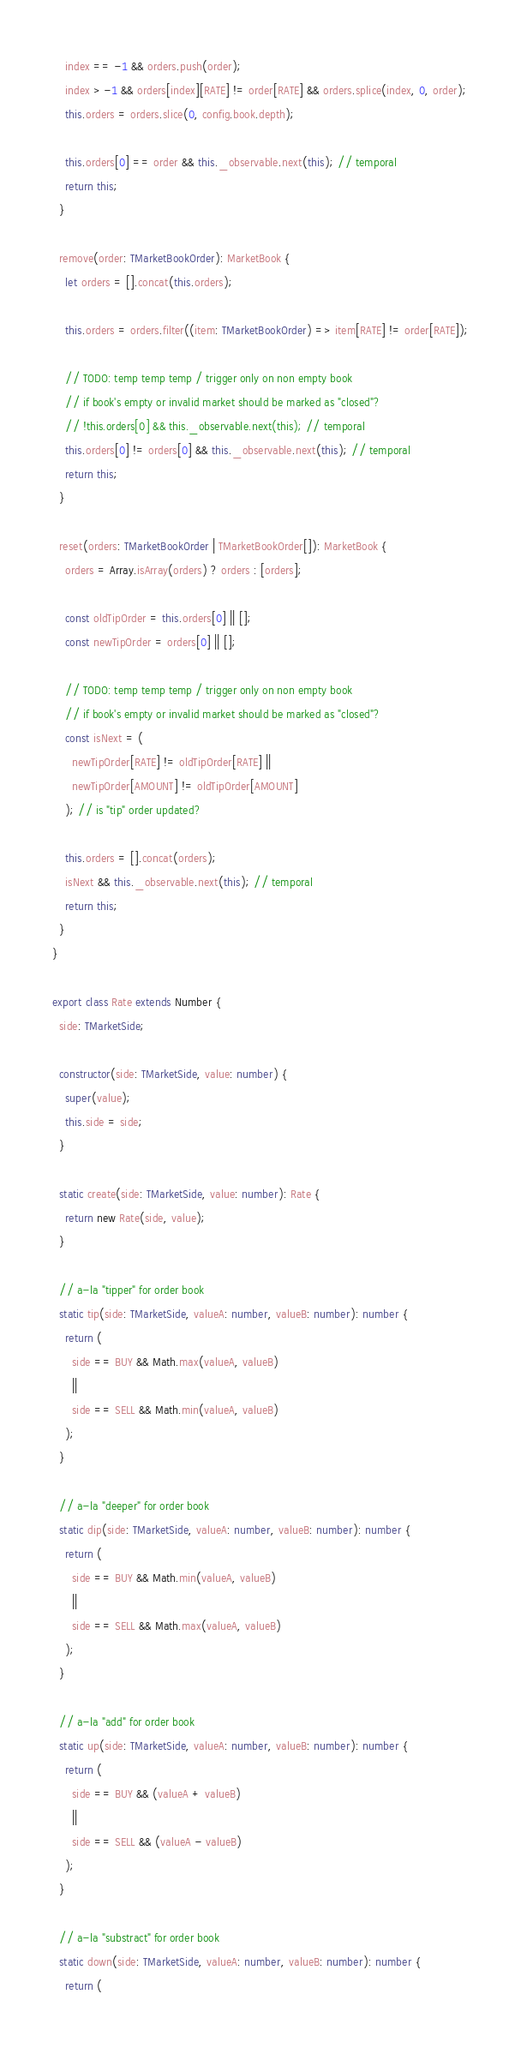<code> <loc_0><loc_0><loc_500><loc_500><_TypeScript_>    index == -1 && orders.push(order);
    index > -1 && orders[index][RATE] != order[RATE] && orders.splice(index, 0, order);
    this.orders = orders.slice(0, config.book.depth);

    this.orders[0] == order && this._observable.next(this); // temporal
    return this;
  }

  remove(order: TMarketBookOrder): MarketBook {
    let orders = [].concat(this.orders);

    this.orders = orders.filter((item: TMarketBookOrder) => item[RATE] != order[RATE]);

    // TODO: temp temp temp / trigger only on non empty book 
    // if book's empty or invalid market should be marked as "closed"?
    // !this.orders[0] && this._observable.next(this); // temporal
    this.orders[0] != orders[0] && this._observable.next(this); // temporal
    return this;
  }

  reset(orders: TMarketBookOrder | TMarketBookOrder[]): MarketBook {
    orders = Array.isArray(orders) ? orders : [orders];

    const oldTipOrder = this.orders[0] || [];
    const newTipOrder = orders[0] || [];

    // TODO: temp temp temp / trigger only on non empty book 
    // if book's empty or invalid market should be marked as "closed"?
    const isNext = (
      newTipOrder[RATE] != oldTipOrder[RATE] ||
      newTipOrder[AMOUNT] != oldTipOrder[AMOUNT]
    ); // is "tip" order updated?

    this.orders = [].concat(orders);
    isNext && this._observable.next(this); // temporal
    return this;
  }
}

export class Rate extends Number {
  side: TMarketSide;

  constructor(side: TMarketSide, value: number) {
    super(value);
    this.side = side;
  }

  static create(side: TMarketSide, value: number): Rate {
    return new Rate(side, value);
  }

  // a-la "tipper" for order book
  static tip(side: TMarketSide, valueA: number, valueB: number): number {
    return (
      side == BUY && Math.max(valueA, valueB)
      ||
      side == SELL && Math.min(valueA, valueB)
    );
  }

  // a-la "deeper" for order book
  static dip(side: TMarketSide, valueA: number, valueB: number): number {
    return (
      side == BUY && Math.min(valueA, valueB)
      ||
      side == SELL && Math.max(valueA, valueB)
    );
  }

  // a-la "add" for order book
  static up(side: TMarketSide, valueA: number, valueB: number): number {
    return (
      side == BUY && (valueA + valueB)
      ||
      side == SELL && (valueA - valueB)
    );
  }

  // a-la "substract" for order book
  static down(side: TMarketSide, valueA: number, valueB: number): number {
    return (</code> 